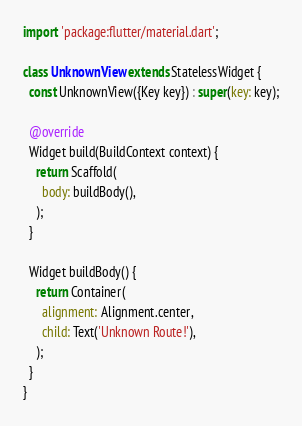Convert code to text. <code><loc_0><loc_0><loc_500><loc_500><_Dart_>import 'package:flutter/material.dart';

class UnknownView extends StatelessWidget {
  const UnknownView({Key key}) : super(key: key);

  @override
  Widget build(BuildContext context) {
    return Scaffold(
      body: buildBody(),
    );
  }

  Widget buildBody() {
    return Container(
      alignment: Alignment.center,
      child: Text('Unknown Route!'),
    );
  }
}
</code> 